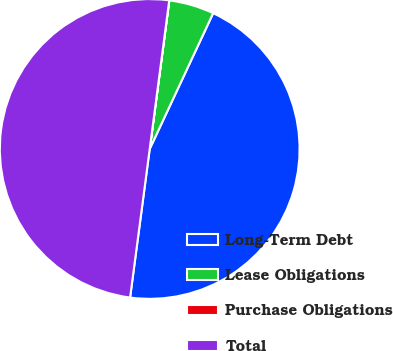<chart> <loc_0><loc_0><loc_500><loc_500><pie_chart><fcel>Long-Term Debt<fcel>Lease Obligations<fcel>Purchase Obligations<fcel>Total<nl><fcel>45.13%<fcel>4.87%<fcel>0.01%<fcel>49.99%<nl></chart> 